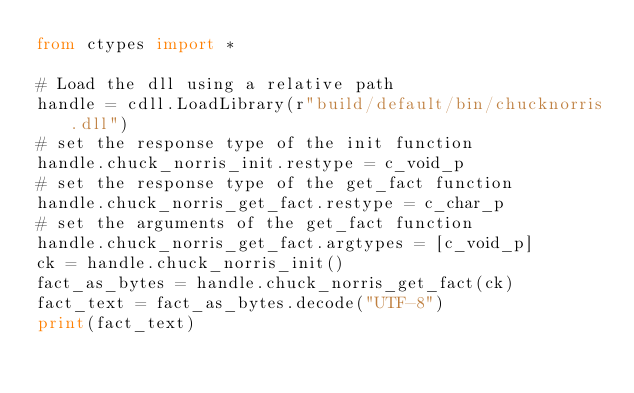<code> <loc_0><loc_0><loc_500><loc_500><_Python_>from ctypes import *

# Load the dll using a relative path
handle = cdll.LoadLibrary(r"build/default/bin/chucknorris.dll")
# set the response type of the init function
handle.chuck_norris_init.restype = c_void_p
# set the response type of the get_fact function
handle.chuck_norris_get_fact.restype = c_char_p
# set the arguments of the get_fact function
handle.chuck_norris_get_fact.argtypes = [c_void_p]
ck = handle.chuck_norris_init()
fact_as_bytes = handle.chuck_norris_get_fact(ck)
fact_text = fact_as_bytes.decode("UTF-8")
print(fact_text)</code> 